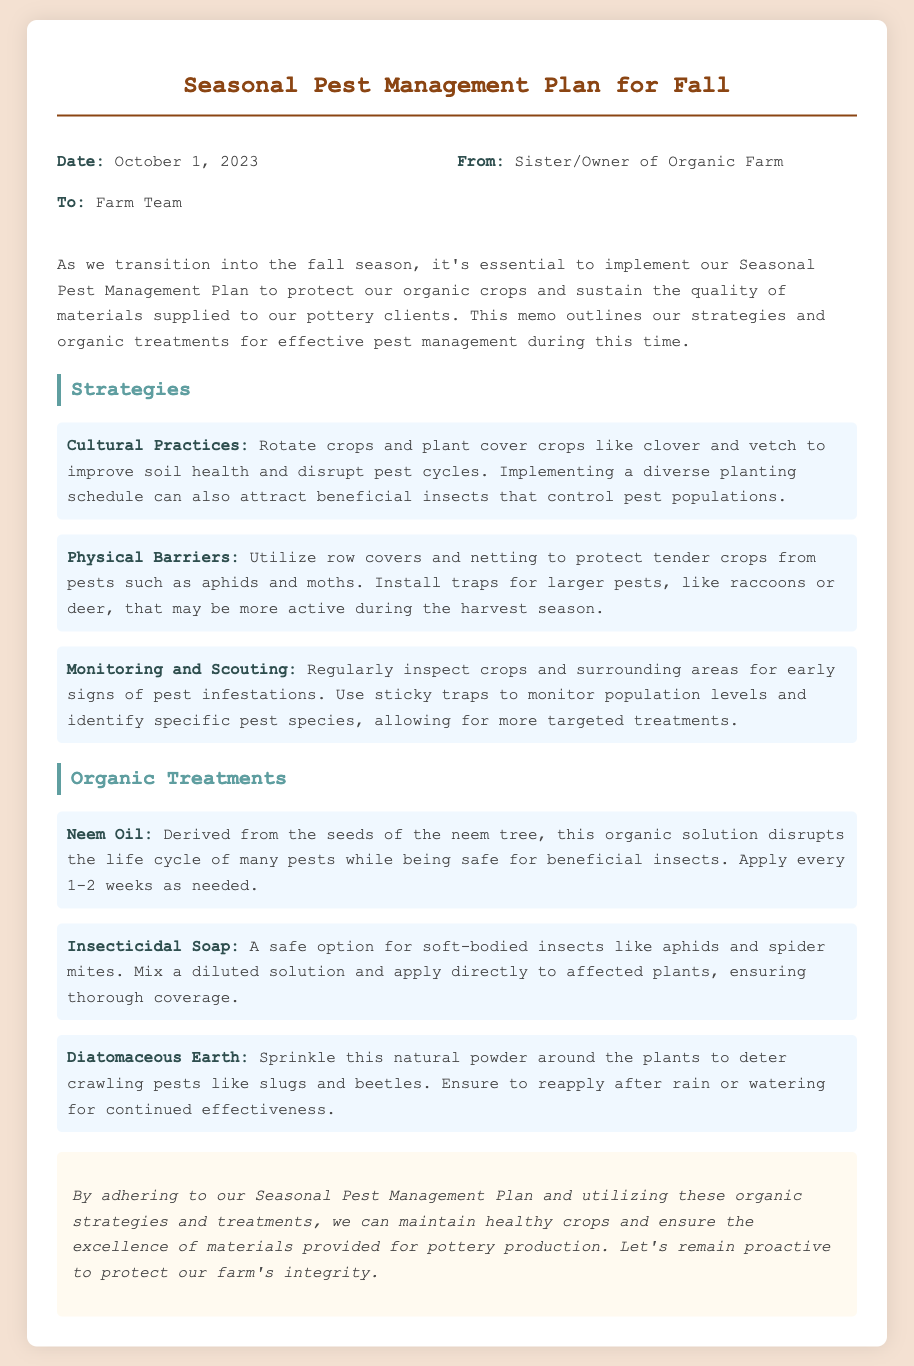What is the date of the memo? The date mentioned in the document is the specific date when the memo was created, which is October 1, 2023.
Answer: October 1, 2023 Who is the memo addressed to? The memo specifies who the intended recipients are, which in this case is the Farm Team.
Answer: Farm Team What are the organic treatments mentioned? The section lists specific organic treatments, thus the answer encompasses all listed treatments in that section.
Answer: Neem Oil, Insecticidal Soap, Diatomaceous Earth What is one of the cultural practices recommended? The document outlines strategies, and one specifically mentioned is rotating crops, improving soil health, and disrupting pest cycles, which can be cited as an example.
Answer: Rotate crops What type of barriers are suggested for pest protection? This refers to a specific strategy employed as described in the document, which includes physical means of protecting crops.
Answer: Physical Barriers How often should Neem Oil be applied? The document provides a recommendation on the frequency of Neem Oil application, which is stated explicitly.
Answer: Every 1-2 weeks What is the main purpose of the Seasonal Pest Management Plan? The introductory section clarifies the purpose of the plan, emphasizing the protection of crops and maintaining quality.
Answer: Protect organic crops What is one method for monitoring pest populations? The document details monitoring strategies, one of which includes using sticky traps to identify specific pest species.
Answer: Sticky traps What is a conclusion drawn about the pest management plan? The conclusion summarizes the overall aim and proactive stance within the pest management context, encapsulating the memo's key point.
Answer: Maintain healthy crops 